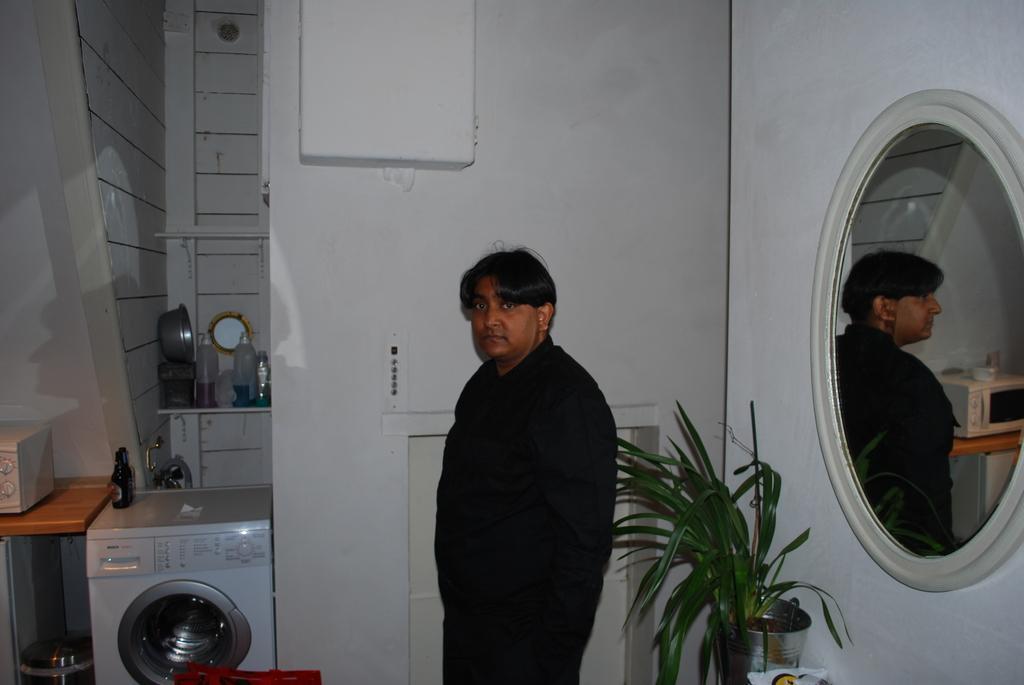Describe this image in one or two sentences. This picture is taken inside the room. In this image, in the middle, we can see a man wearing black color dress. On the right side, we can see a mirror is attached to a wall, in the mirror, we can see a man and a table, on that table, we can see a microwave oven. On the right side, we can see a plant. On the left side, we can see a washing machine. On the washing machine, we can see a bottle, on that table, we can see a microwave oven. In the background, we can see a table with some metal instrument and bottles and a wall which is in white color. 